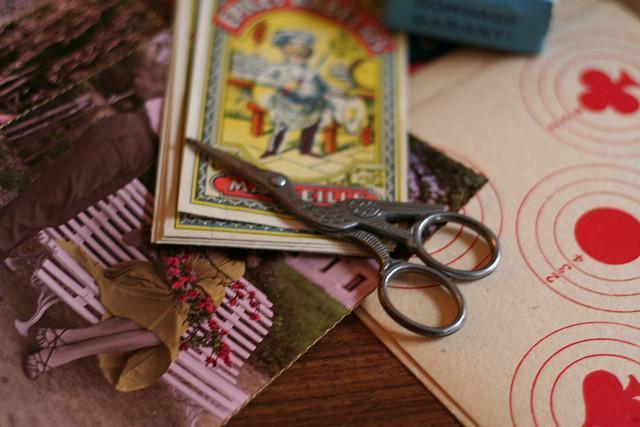How many heart shapes are visible?
Give a very brief answer. 0. How many scissors are on the board?
Give a very brief answer. 1. How many people can be seen?
Give a very brief answer. 2. How many sandwiches are on the plate?
Give a very brief answer. 0. 